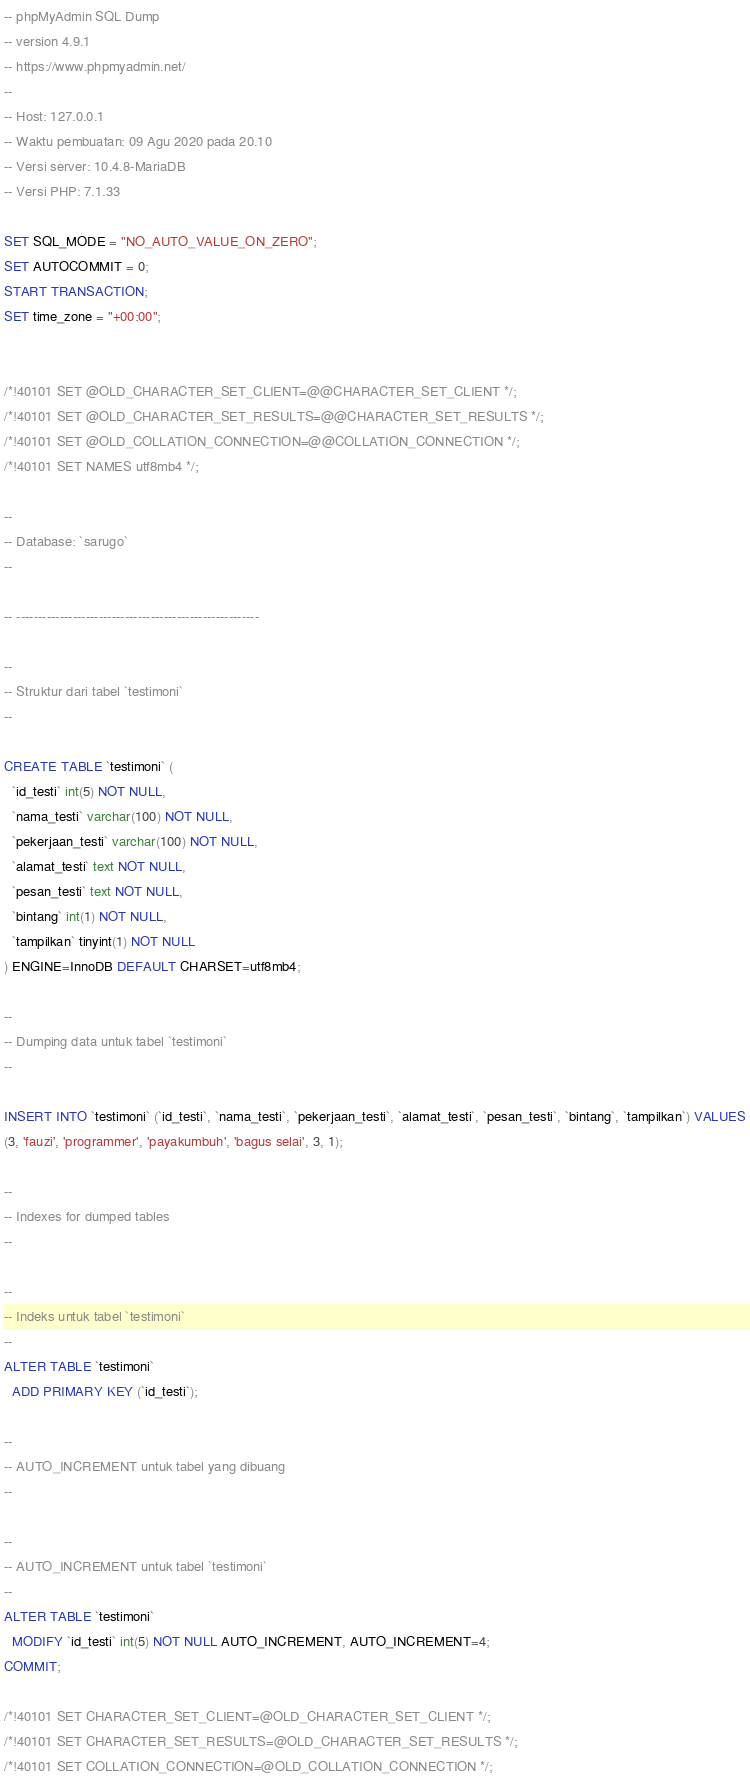<code> <loc_0><loc_0><loc_500><loc_500><_SQL_>-- phpMyAdmin SQL Dump
-- version 4.9.1
-- https://www.phpmyadmin.net/
--
-- Host: 127.0.0.1
-- Waktu pembuatan: 09 Agu 2020 pada 20.10
-- Versi server: 10.4.8-MariaDB
-- Versi PHP: 7.1.33

SET SQL_MODE = "NO_AUTO_VALUE_ON_ZERO";
SET AUTOCOMMIT = 0;
START TRANSACTION;
SET time_zone = "+00:00";


/*!40101 SET @OLD_CHARACTER_SET_CLIENT=@@CHARACTER_SET_CLIENT */;
/*!40101 SET @OLD_CHARACTER_SET_RESULTS=@@CHARACTER_SET_RESULTS */;
/*!40101 SET @OLD_COLLATION_CONNECTION=@@COLLATION_CONNECTION */;
/*!40101 SET NAMES utf8mb4 */;

--
-- Database: `sarugo`
--

-- --------------------------------------------------------

--
-- Struktur dari tabel `testimoni`
--

CREATE TABLE `testimoni` (
  `id_testi` int(5) NOT NULL,
  `nama_testi` varchar(100) NOT NULL,
  `pekerjaan_testi` varchar(100) NOT NULL,
  `alamat_testi` text NOT NULL,
  `pesan_testi` text NOT NULL,
  `bintang` int(1) NOT NULL,
  `tampilkan` tinyint(1) NOT NULL
) ENGINE=InnoDB DEFAULT CHARSET=utf8mb4;

--
-- Dumping data untuk tabel `testimoni`
--

INSERT INTO `testimoni` (`id_testi`, `nama_testi`, `pekerjaan_testi`, `alamat_testi`, `pesan_testi`, `bintang`, `tampilkan`) VALUES
(3, 'fauzi', 'programmer', 'payakumbuh', 'bagus selai', 3, 1);

--
-- Indexes for dumped tables
--

--
-- Indeks untuk tabel `testimoni`
--
ALTER TABLE `testimoni`
  ADD PRIMARY KEY (`id_testi`);

--
-- AUTO_INCREMENT untuk tabel yang dibuang
--

--
-- AUTO_INCREMENT untuk tabel `testimoni`
--
ALTER TABLE `testimoni`
  MODIFY `id_testi` int(5) NOT NULL AUTO_INCREMENT, AUTO_INCREMENT=4;
COMMIT;

/*!40101 SET CHARACTER_SET_CLIENT=@OLD_CHARACTER_SET_CLIENT */;
/*!40101 SET CHARACTER_SET_RESULTS=@OLD_CHARACTER_SET_RESULTS */;
/*!40101 SET COLLATION_CONNECTION=@OLD_COLLATION_CONNECTION */;
</code> 